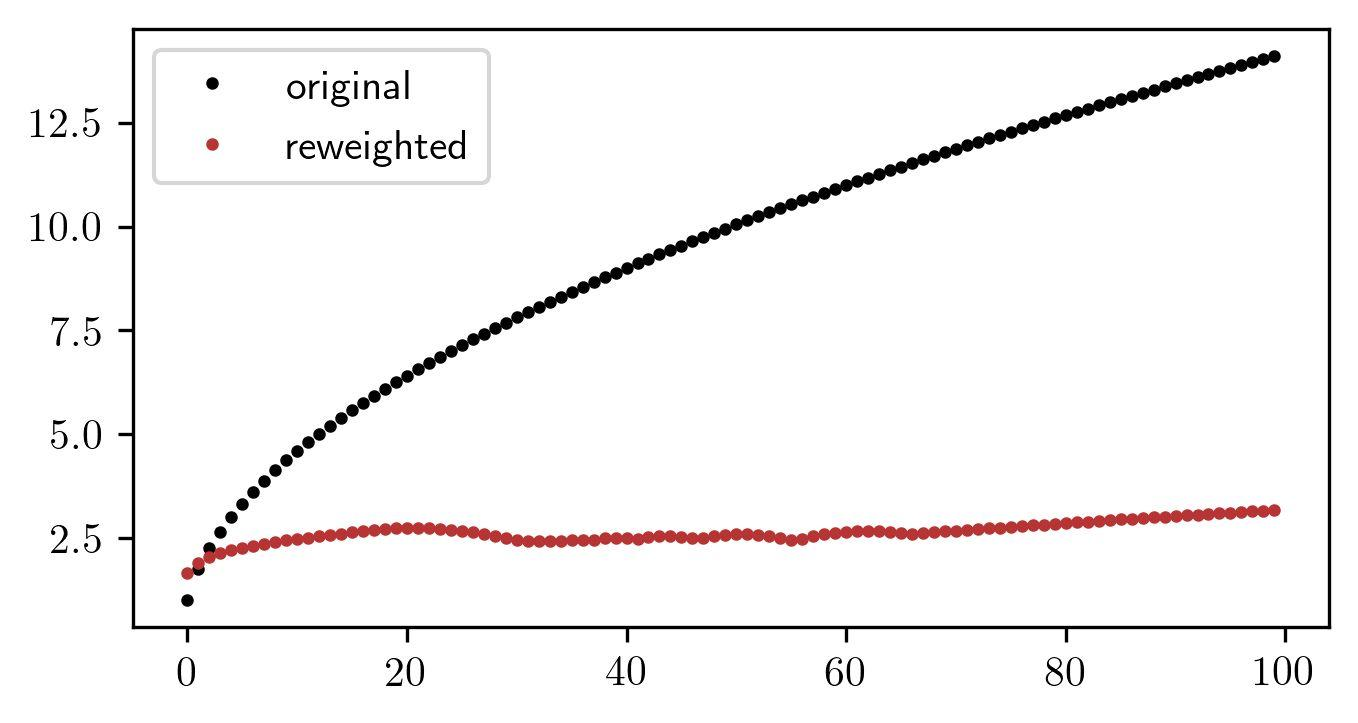Based on the graph, what is the approximate range of values for the reweighted data points? A. 0 to 2.5 B. 2.5 to 5.0 C. 0 to 10.0 D. 0 to 12.5 Upon examining the graph, the reweighted data points are designated by the red color. These points can be seen lying consistently within the lower margin of the y-axis, which extends from 0 upwards but does not surpass the 2.5 mark. Crucially, the horizontal spread of the data suggests a wide range of x-values, though this does not impact the y-value range in question. Consequently, the correct answer to the approximate range of reweighted data point values is indeed A. 0 to 2.5. 